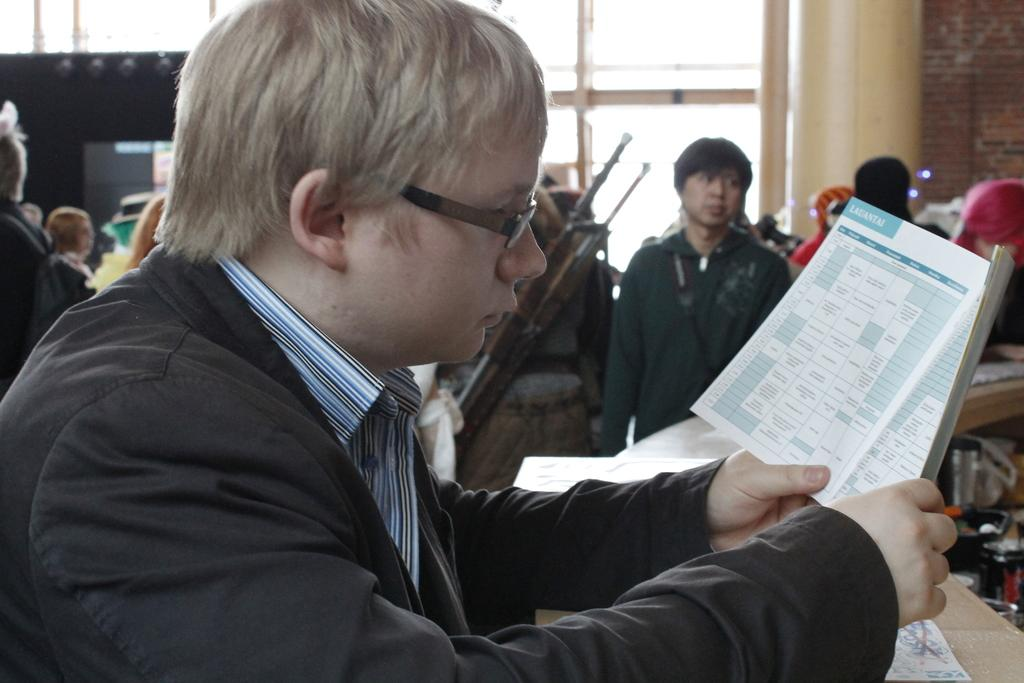What is the main subject of the picture? The main subject of the picture is a man. Can you describe the man's appearance? The man is wearing spectacles and a blazer. What is the man holding in the picture? The man is holding a book. What can be seen in the background of the image? There is a group of people, objects, and a wall visible in the background of the image. Can you tell me how many cats are visible in the image? There are no cats present in the image. What type of stream is flowing in the background of the image? There is no stream visible in the image; it features a man, a book, and a background with people, objects, and a wall. 